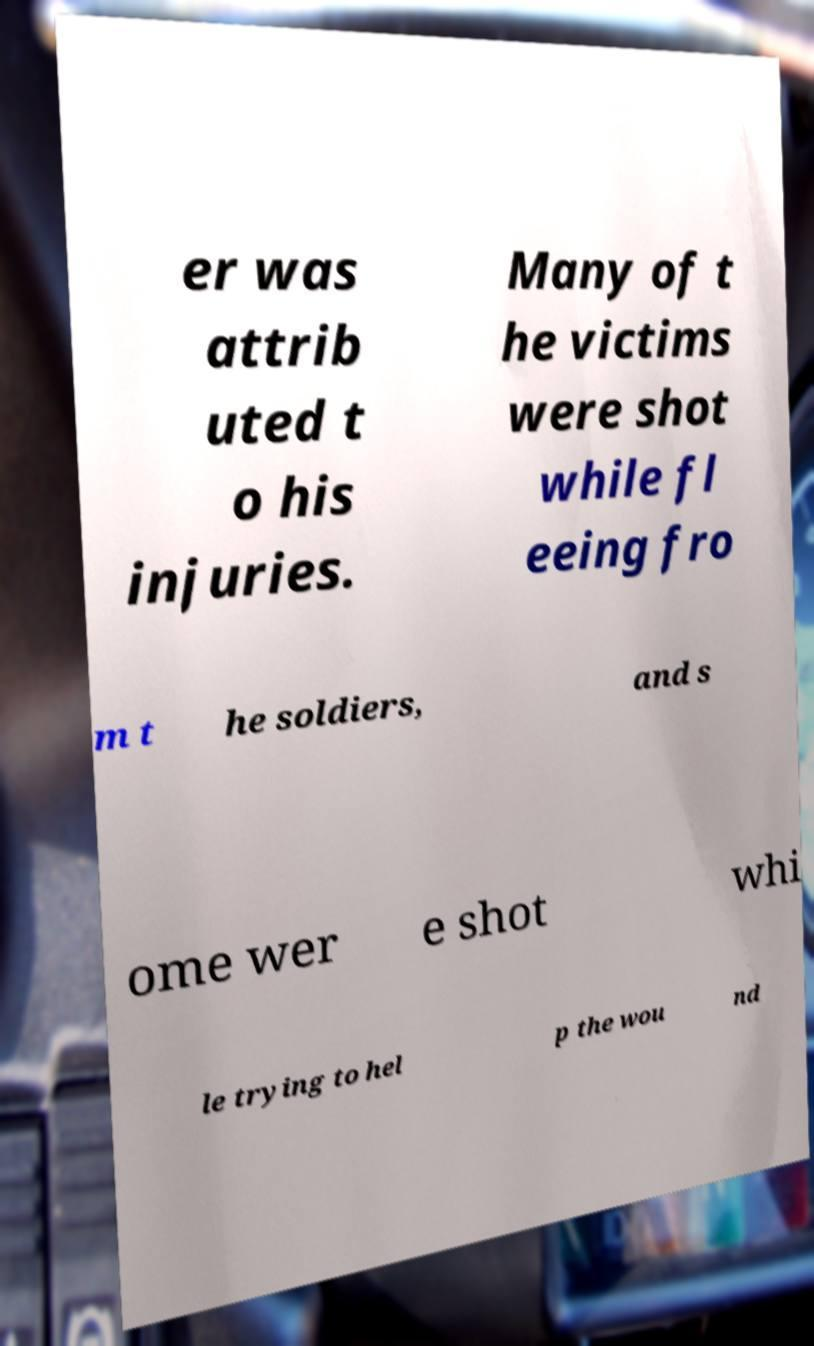I need the written content from this picture converted into text. Can you do that? er was attrib uted t o his injuries. Many of t he victims were shot while fl eeing fro m t he soldiers, and s ome wer e shot whi le trying to hel p the wou nd 